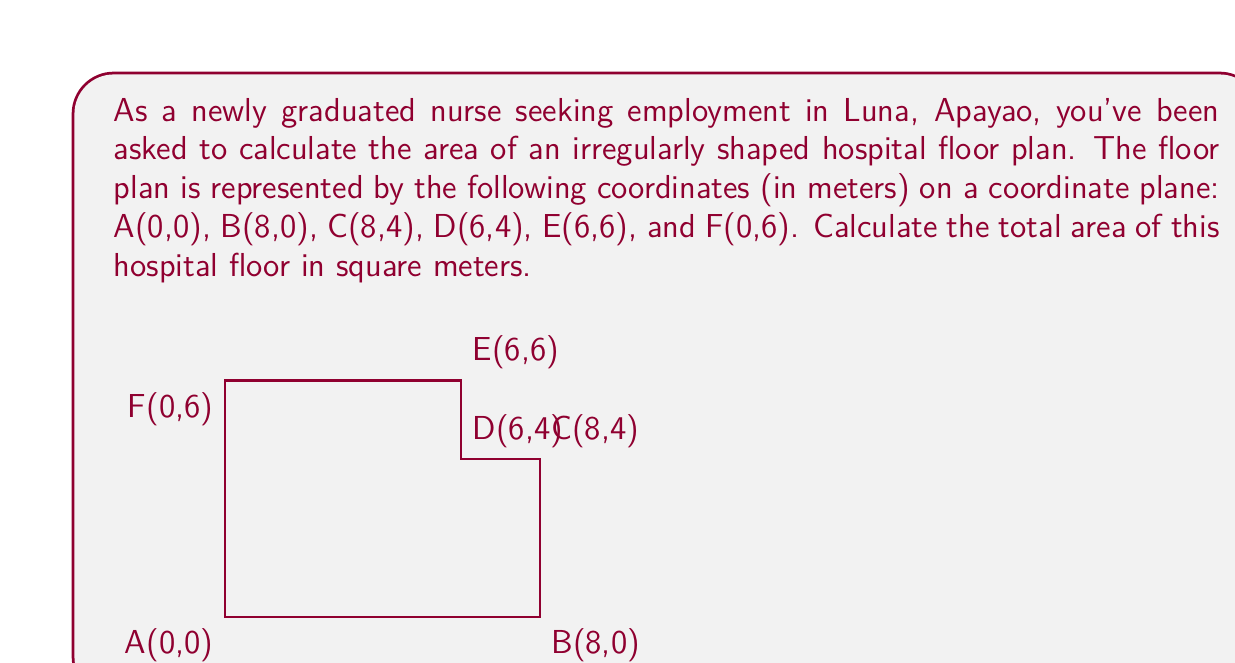Can you solve this math problem? To calculate the area of this irregular shape, we can divide it into rectangles:

1. Rectangle ABCF: 
   Width = 8 m, Height = 4 m
   Area_1 = $8 \times 4 = 32$ m²

2. Rectangle DEFC:
   Width = 6 m, Height = 2 m
   Area_2 = $6 \times 2 = 12$ m²

The total area is the sum of these two rectangles:

$$\text{Total Area} = \text{Area}_1 + \text{Area}_2$$
$$\text{Total Area} = 32 \text{ m}^2 + 12 \text{ m}^2 = 44 \text{ m}^2$$

Alternatively, we can use the Shoelace formula (also known as the surveyor's formula) to calculate the area:

$$A = \frac{1}{2}|(x_1y_2 + x_2y_3 + ... + x_ny_1) - (y_1x_2 + y_2x_3 + ... + y_nx_1)|$$

Where $(x_i, y_i)$ are the coordinates of each vertex.

$$\begin{align*}
A &= \frac{1}{2}|[(0 \times 0) + (8 \times 4) + (8 \times 4) + (6 \times 6) + (6 \times 6) + (0 \times 0)] \\
&\quad - [(0 \times 8) + (0 \times 8) + (4 \times 6) + (4 \times 6) + (6 \times 0) + (6 \times 0)]| \\
&= \frac{1}{2}|(0 + 32 + 32 + 36 + 36 + 0) - (0 + 0 + 24 + 24 + 0 + 0)| \\
&= \frac{1}{2}|136 - 48| \\
&= \frac{1}{2} \times 88 \\
&= 44 \text{ m}^2
\end{align*}$$

Both methods yield the same result, confirming the accuracy of our calculation.
Answer: 44 m² 